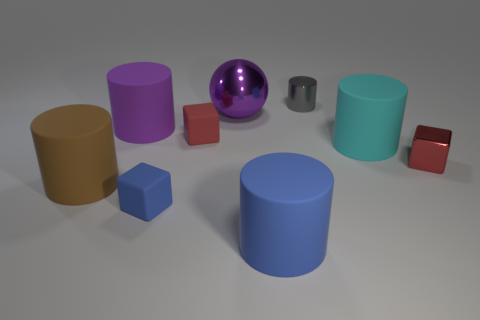What number of other objects are there of the same shape as the big purple metal thing?
Give a very brief answer. 0. Is the number of matte objects less than the number of big purple spheres?
Your answer should be compact. No. What size is the rubber cylinder that is behind the big brown cylinder and on the right side of the purple rubber cylinder?
Offer a terse response. Large. There is a purple object that is right of the matte block in front of the tiny red thing that is to the left of the red metal object; how big is it?
Ensure brevity in your answer.  Large. The brown object has what size?
Your answer should be very brief. Large. There is a large purple thing on the right side of the large rubber thing behind the cyan matte object; is there a big brown matte cylinder that is in front of it?
Provide a succinct answer. Yes. What number of big objects are either gray metal cylinders or brown rubber spheres?
Keep it short and to the point. 0. Is there anything else that is the same color as the large ball?
Make the answer very short. Yes. Does the matte cube in front of the brown rubber object have the same size as the red metallic thing?
Keep it short and to the point. Yes. The tiny block in front of the tiny cube that is right of the blue object that is in front of the small blue block is what color?
Offer a very short reply. Blue. 